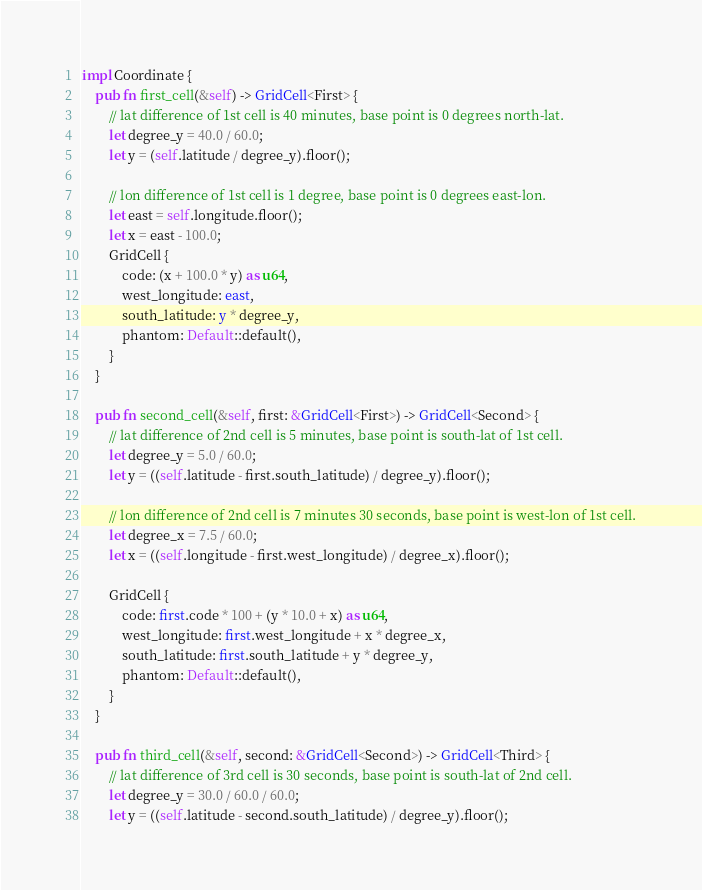Convert code to text. <code><loc_0><loc_0><loc_500><loc_500><_Rust_>
impl Coordinate {
    pub fn first_cell(&self) -> GridCell<First> {
        // lat difference of 1st cell is 40 minutes, base point is 0 degrees north-lat.
        let degree_y = 40.0 / 60.0;
        let y = (self.latitude / degree_y).floor();

        // lon difference of 1st cell is 1 degree, base point is 0 degrees east-lon.
        let east = self.longitude.floor();
        let x = east - 100.0;
        GridCell {
            code: (x + 100.0 * y) as u64,
            west_longitude: east,
            south_latitude: y * degree_y,
            phantom: Default::default(),
        }
    }

    pub fn second_cell(&self, first: &GridCell<First>) -> GridCell<Second> {
        // lat difference of 2nd cell is 5 minutes, base point is south-lat of 1st cell.
        let degree_y = 5.0 / 60.0;
        let y = ((self.latitude - first.south_latitude) / degree_y).floor();

        // lon difference of 2nd cell is 7 minutes 30 seconds, base point is west-lon of 1st cell.
        let degree_x = 7.5 / 60.0;
        let x = ((self.longitude - first.west_longitude) / degree_x).floor();

        GridCell {
            code: first.code * 100 + (y * 10.0 + x) as u64,
            west_longitude: first.west_longitude + x * degree_x,
            south_latitude: first.south_latitude + y * degree_y,
            phantom: Default::default(),
        }
    }

    pub fn third_cell(&self, second: &GridCell<Second>) -> GridCell<Third> {
        // lat difference of 3rd cell is 30 seconds, base point is south-lat of 2nd cell.
        let degree_y = 30.0 / 60.0 / 60.0;
        let y = ((self.latitude - second.south_latitude) / degree_y).floor();
</code> 